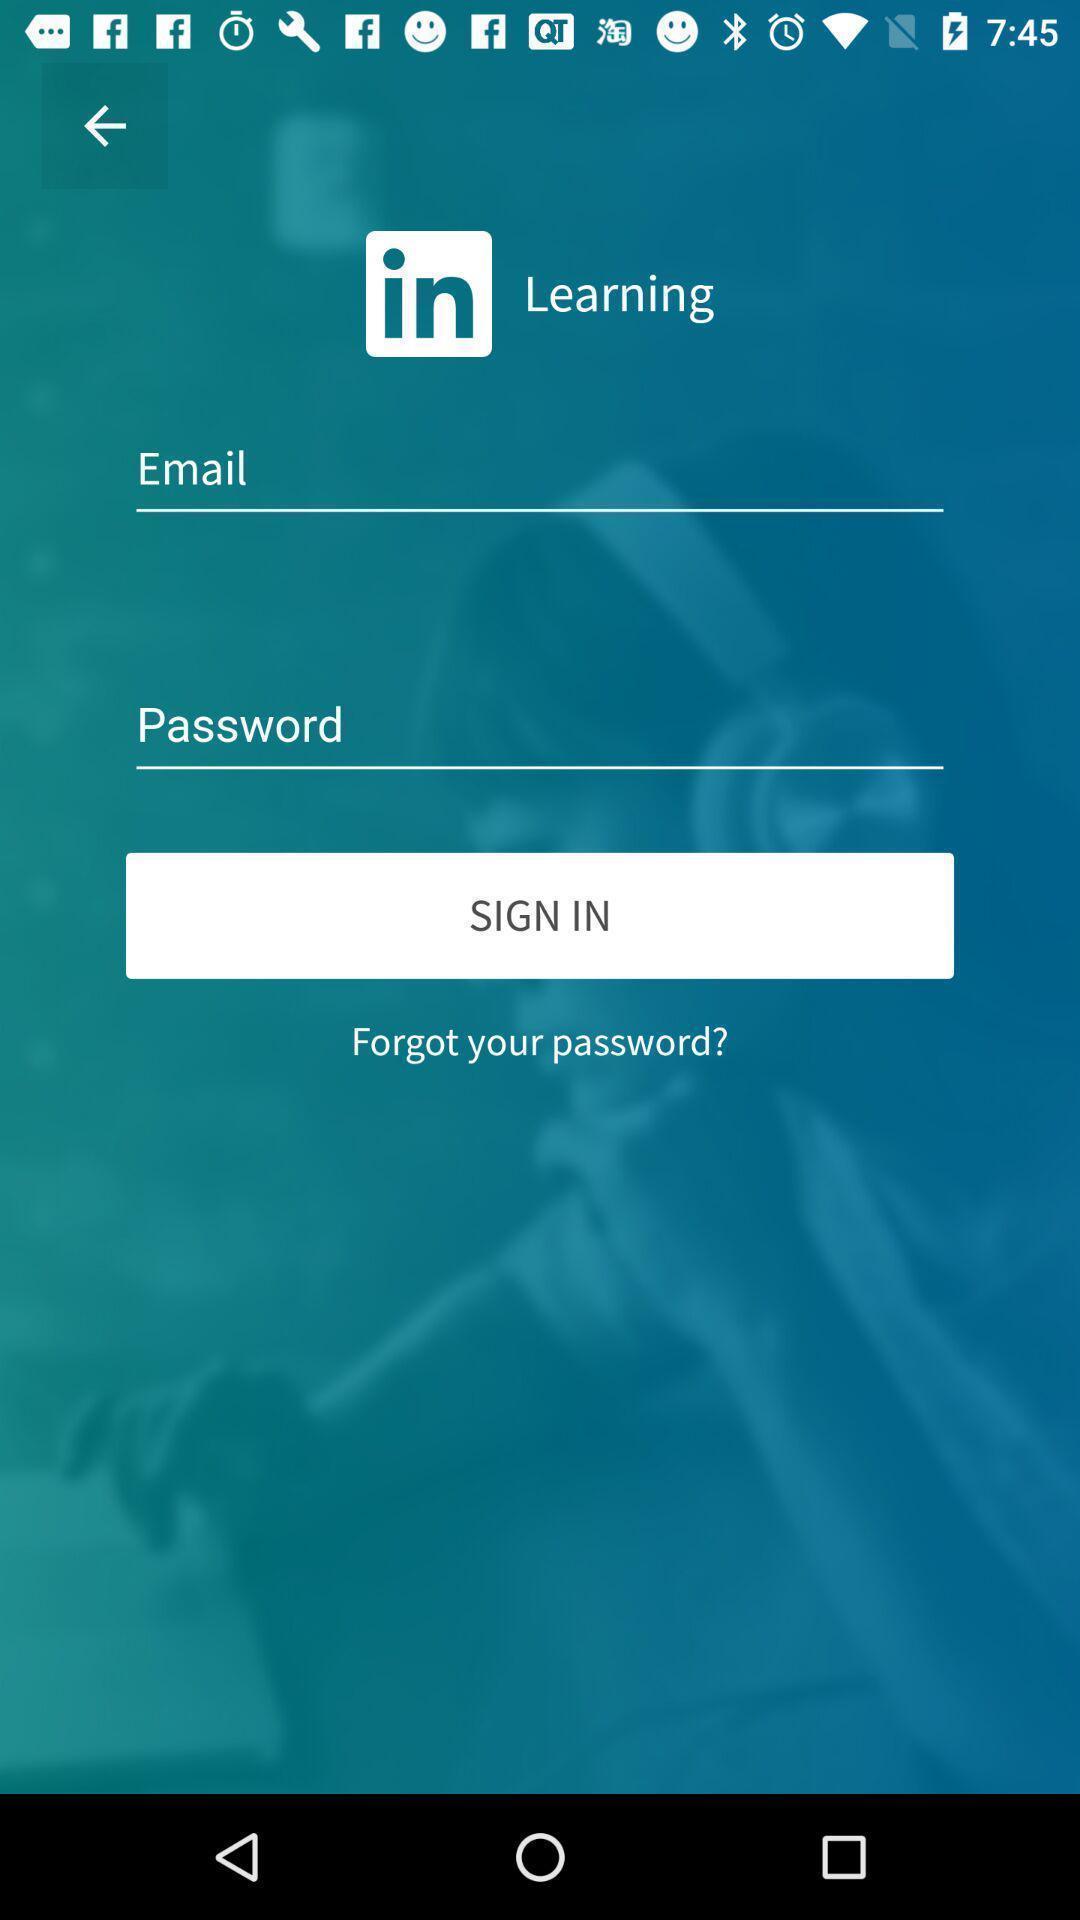Provide a detailed account of this screenshot. Sign in page of a learning application. 